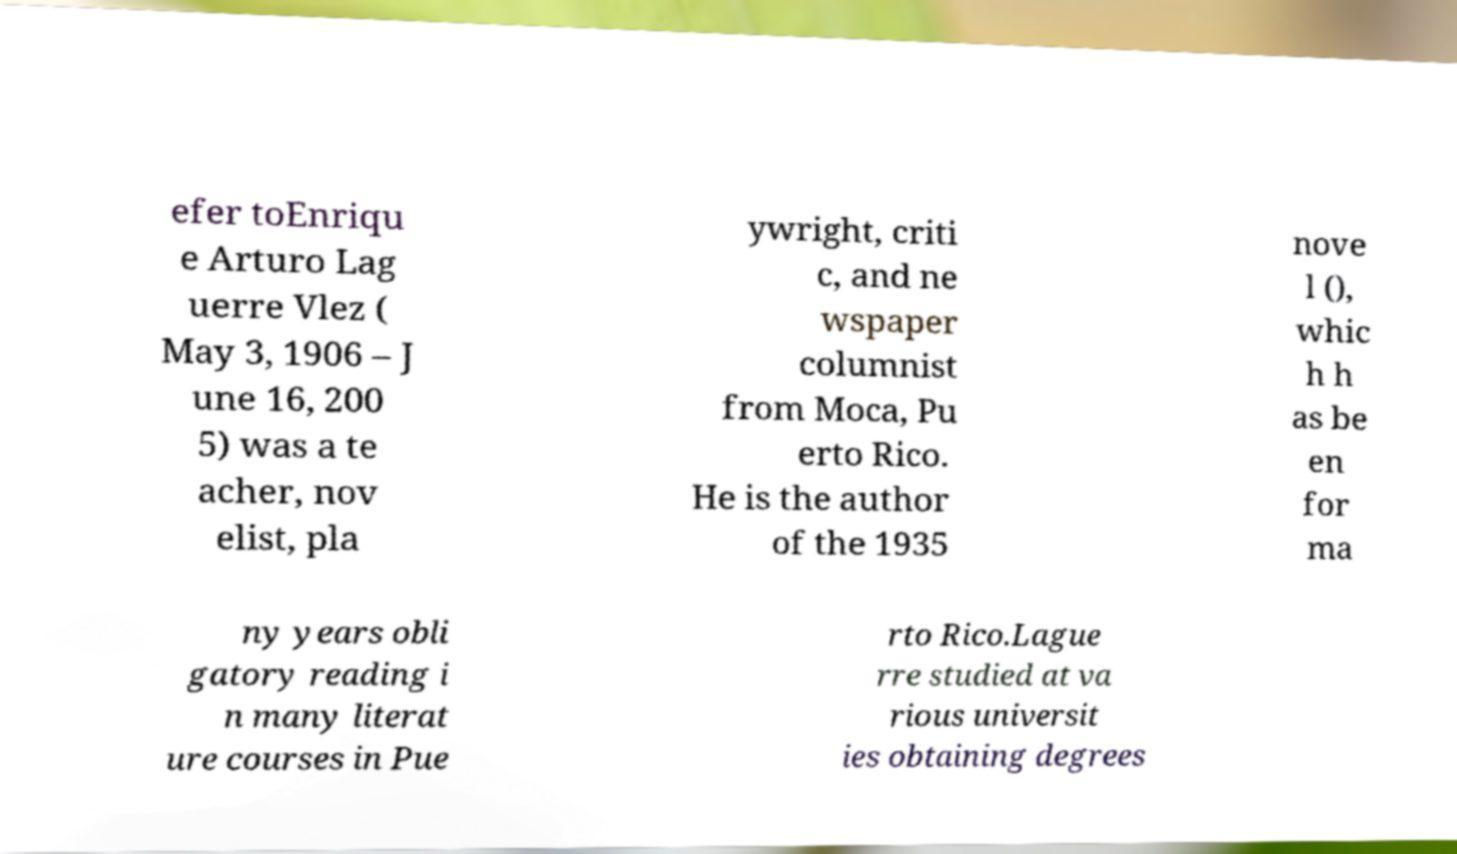I need the written content from this picture converted into text. Can you do that? efer toEnriqu e Arturo Lag uerre Vlez ( May 3, 1906 – J une 16, 200 5) was a te acher, nov elist, pla ywright, criti c, and ne wspaper columnist from Moca, Pu erto Rico. He is the author of the 1935 nove l (), whic h h as be en for ma ny years obli gatory reading i n many literat ure courses in Pue rto Rico.Lague rre studied at va rious universit ies obtaining degrees 